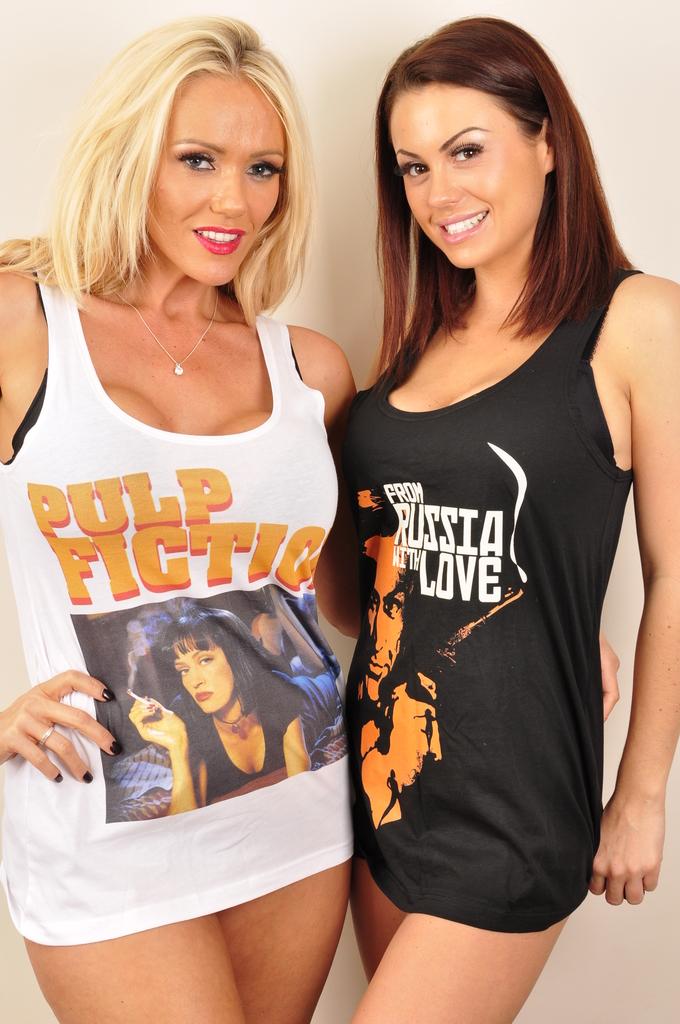What movie title is on the black shirt?
Make the answer very short. From russia with love. 